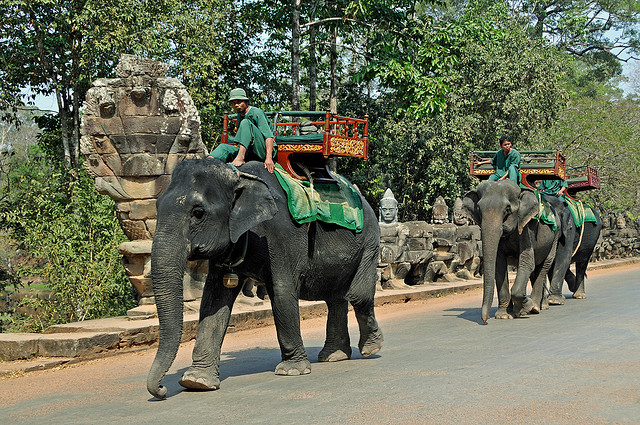Which country is famous for elephants?
A. dutch
B. norway
C. sydney
D. thailand
Answer with the option's letter from the given choices directly. D 